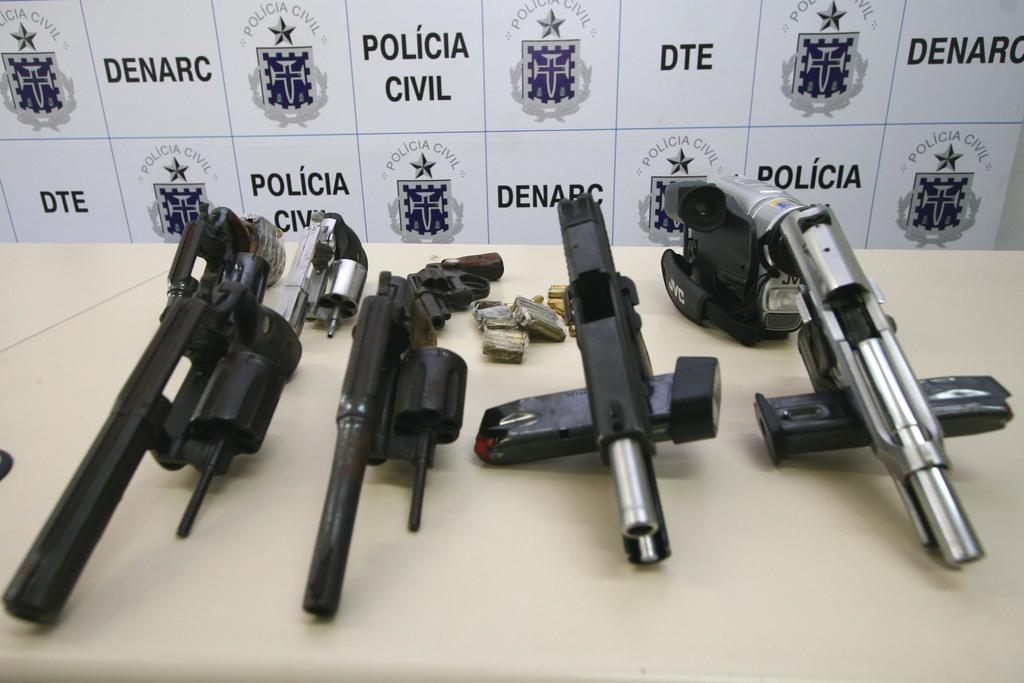What types of objects are present on the table in the image? There are different kinds of weapons in the image, and they are placed on a table. What can be seen in the background of the image? There is a white color board in the background of the image. What is written or displayed on the white color board? The white color board has edited text on it. Are there any logos or symbols on the white color board? Yes, the white color board has logos on it. What type of balloon can be seen floating near the weapons in the image? There is no balloon present in the image; the focus is on the weapons and the white color board in the background. How many seats are visible in the image? There is no mention of seats in the image; the focus is on the weapons and the white color board in the background. --- Facts: 1. There is a person sitting on a chair in the image. 2. The person is holding a book. 3. The book has a blue cover. 4. The chair is made of wood. 5. There is a window behind the person. Absurd Topics: parrot, bicycle, ocean Conversation: What is the person in the image doing? The person is sitting on a chair in the image. What is the person holding in the image? The person is holding a book in the image. What can be said about the book's appearance? The book has a blue cover. What is the chair made of? The chair is made of wood. What can be seen behind the person in the image? There is a window behind the person in the image. Reasoning: Let's think step by step in order to produce the conversation. We start by identifying the main subject in the image, which is the person sitting on the chair. Then, we expand the conversation to include the book the person is holding, describing its appearance. Next, we mention the chair's material and finally, we describe the background of the image, focusing on the window. Absurd Question/Answer: What type of parrot is sitting on the bicycle outside the window in the image? There is no parrot or bicycle present in the image; the focus is on the person sitting on the chair, holding a book, and the window in the background. --- Facts: 1. There is a person standing in front of a mirror in the image. 2. The person is wearing a red shirt. 3. The mirror has a wooden frame. 4. There is a light fixture above the mirror. 5. The light fixture has a circular shape. Absurd Topics: elephant, sand, umbrella Conversation: What is the person in the image doing? The person is standing in front of a mirror in the image. 